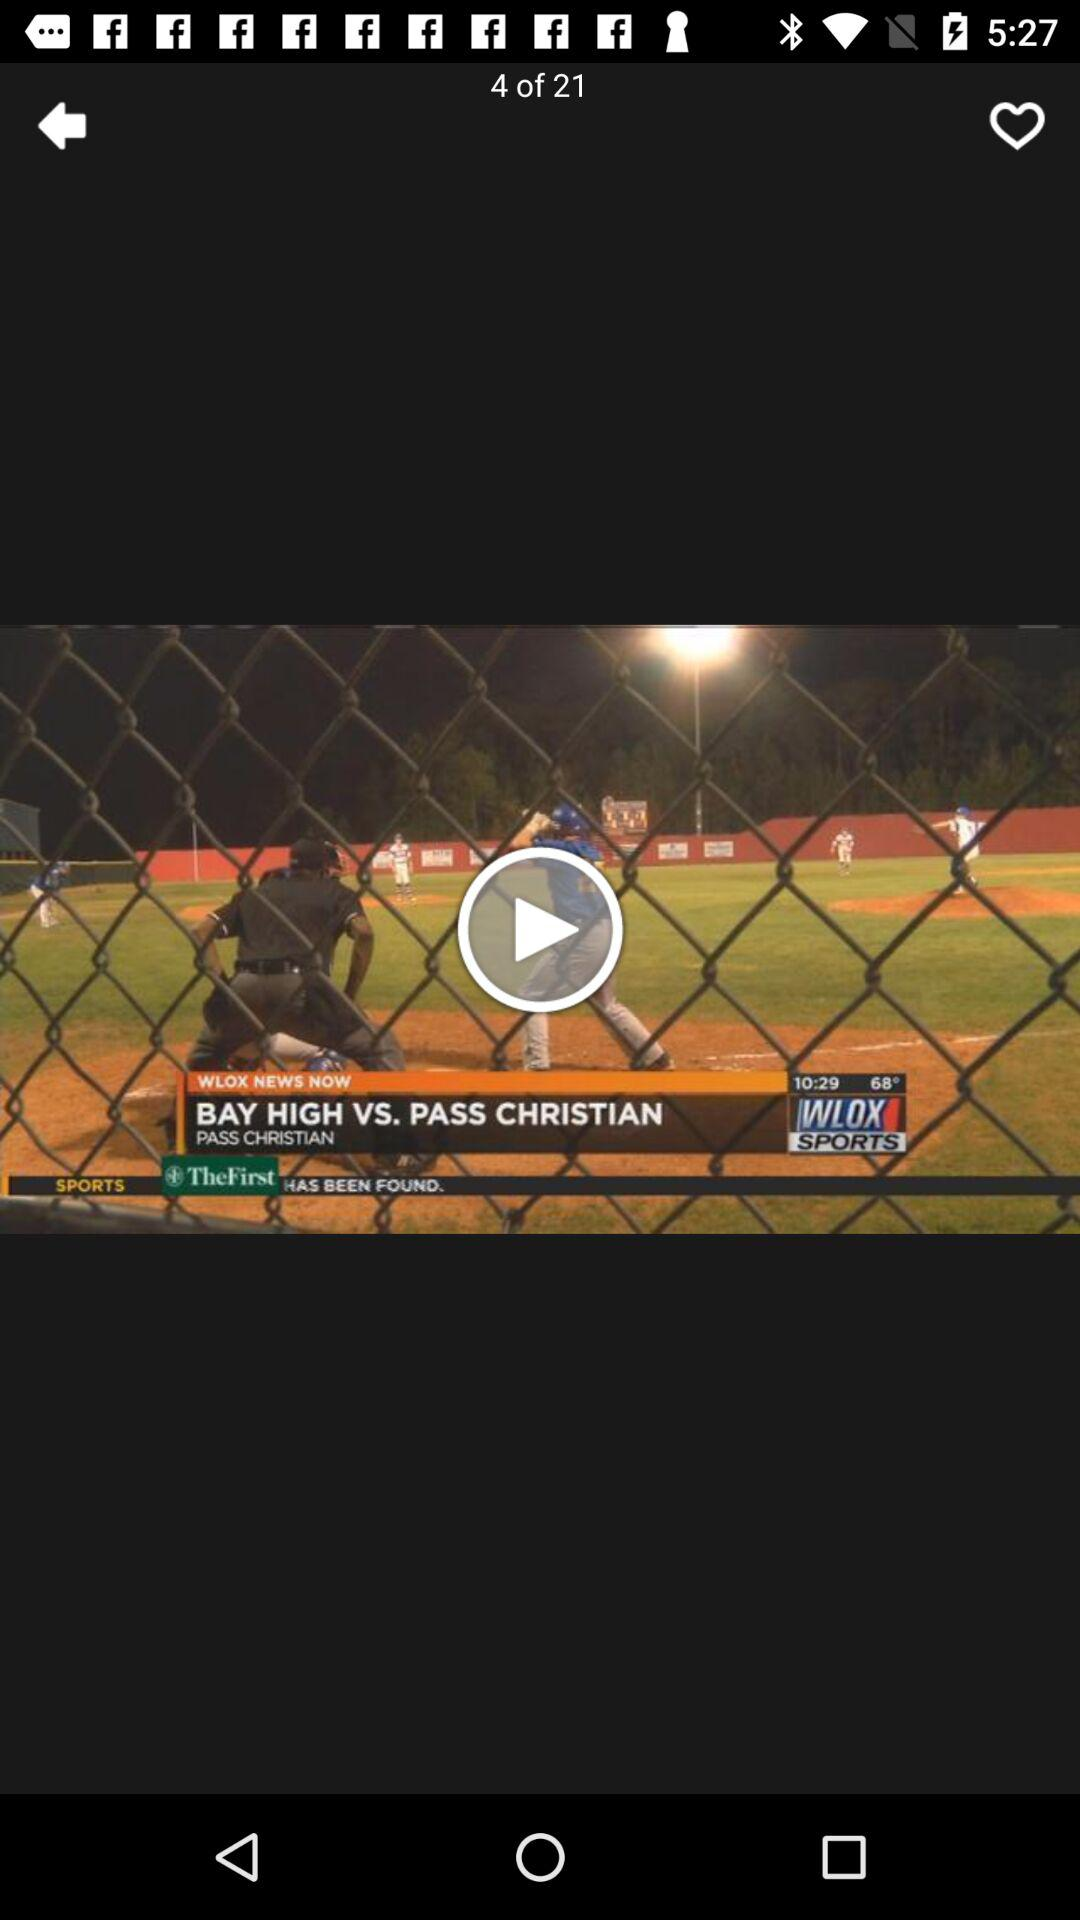What is the total number of videos? The total number of videos is 21. 